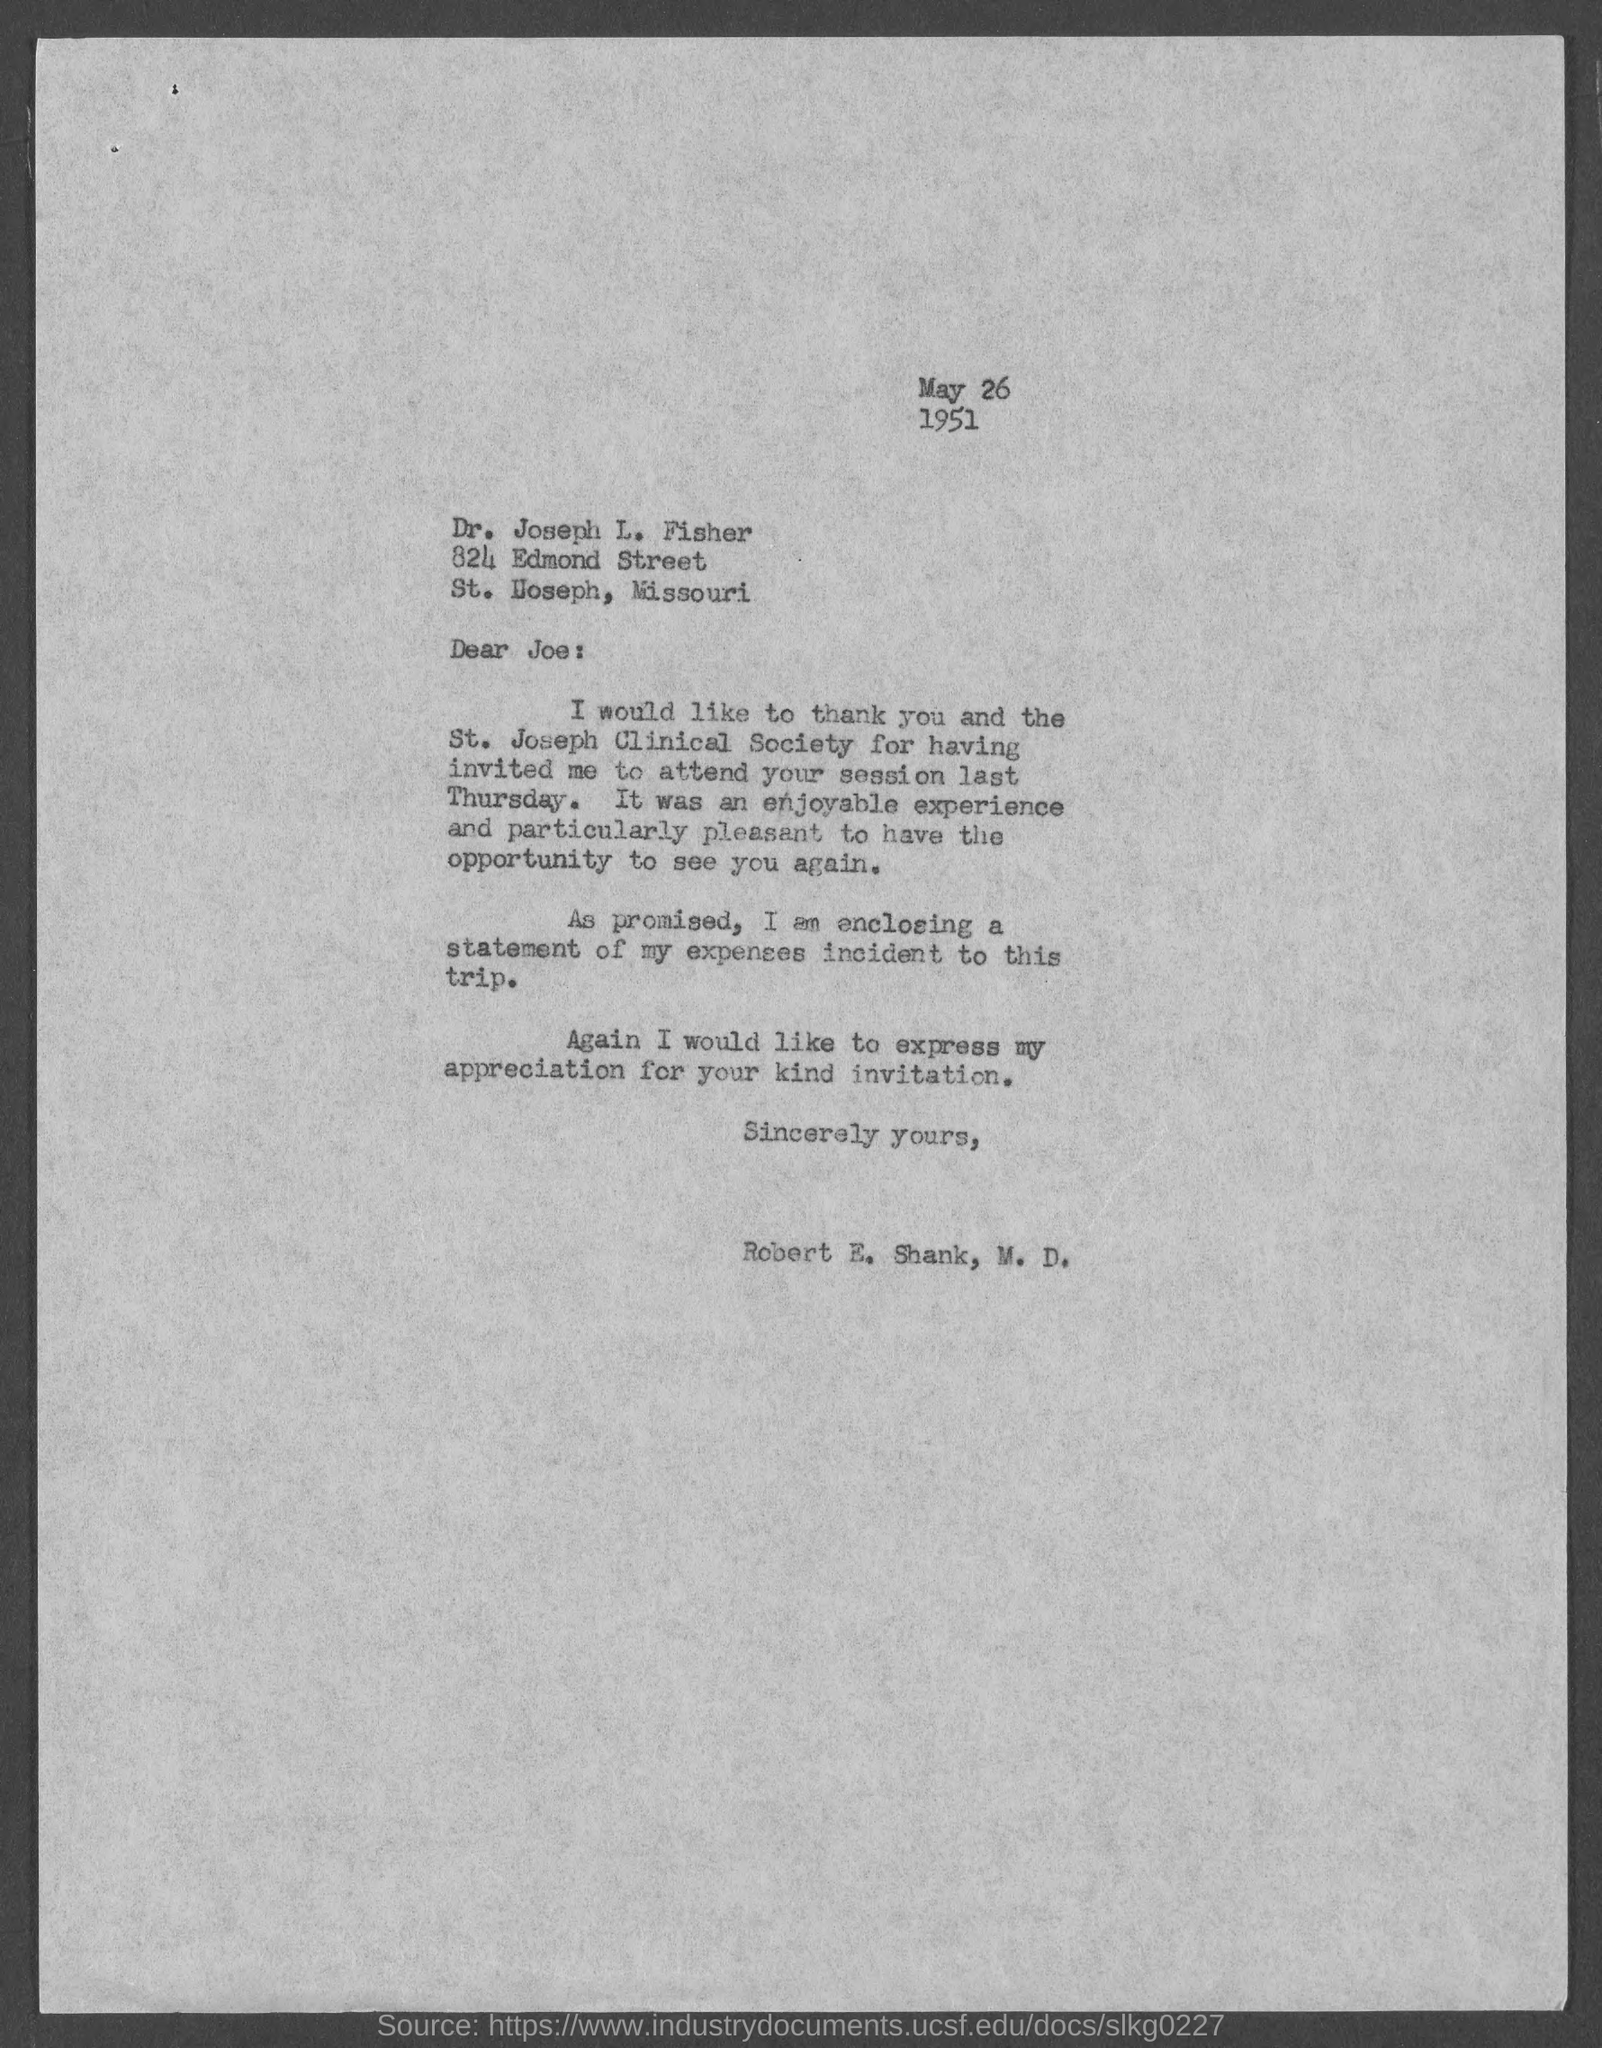What is the date mentioned in this letter?
Offer a terse response. May 26  1951. 